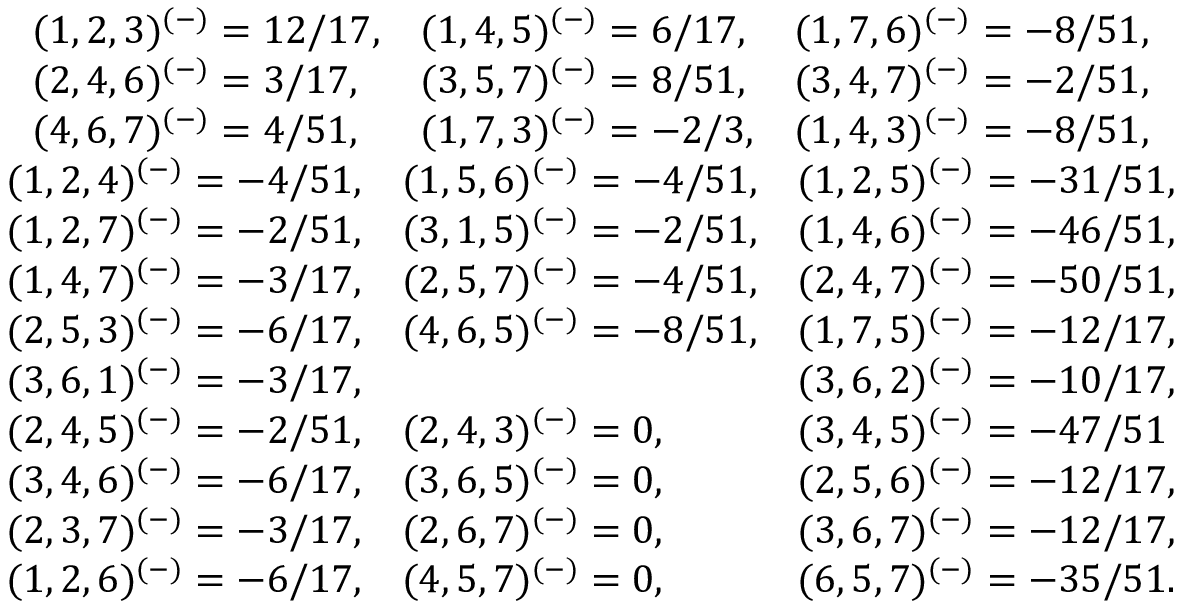Convert formula to latex. <formula><loc_0><loc_0><loc_500><loc_500>\begin{array} { c } { { \begin{array} { l l l } { { ( 1 , 2 , 3 ) ^ { ( - ) } = 1 2 / 1 7 , } } & { { ( 1 , 4 , 5 ) ^ { ( - ) } = 6 / 1 7 , } } & { { ( 1 , 7 , 6 ) ^ { ( - ) } = - 8 / 5 1 , } } \\ { { ( 2 , 4 , 6 ) ^ { ( - ) } = 3 / 1 7 , } } & { { ( 3 , 5 , 7 ) ^ { ( - ) } = 8 / 5 1 , } } & { { ( 3 , 4 , 7 ) ^ { ( - ) } = - 2 / 5 1 , } } \\ { { ( 4 , 6 , 7 ) ^ { ( - ) } = 4 / 5 1 , } } & { { ( 1 , 7 , 3 ) ^ { ( - ) } = - 2 / 3 , } } & { { ( 1 , 4 , 3 ) ^ { ( - ) } = - 8 / 5 1 , } } \end{array} } } \\ { { \begin{array} { l l l } { { ( 1 , 2 , 4 ) ^ { ( - ) } = - 4 / 5 1 , } } & { { ( 1 , 5 , 6 ) ^ { ( - ) } = - 4 / 5 1 , } } & { { ( 1 , 2 , 5 ) ^ { ( - ) } = - 3 1 / 5 1 , } } \\ { { ( 1 , 2 , 7 ) ^ { ( - ) } = - 2 / 5 1 , } } & { { ( 3 , 1 , 5 ) ^ { ( - ) } = - 2 / 5 1 , } } & { { ( 1 , 4 , 6 ) ^ { ( - ) } = - 4 6 / 5 1 , } } \\ { { ( 1 , 4 , 7 ) ^ { ( - ) } = - 3 / 1 7 , } } & { { ( 2 , 5 , 7 ) ^ { ( - ) } = - 4 / 5 1 , } } & { { ( 2 , 4 , 7 ) ^ { ( - ) } = - 5 0 / 5 1 , } } \\ { { ( 2 , 5 , 3 ) ^ { ( - ) } = - 6 / 1 7 , } } & { { ( 4 , 6 , 5 ) ^ { ( - ) } = - 8 / 5 1 , } } & { { ( 1 , 7 , 5 ) ^ { ( - ) } = - 1 2 / 1 7 , } } \\ { { ( 3 , 6 , 1 ) ^ { ( - ) } = - 3 / 1 7 , } } & { { ( 3 , 6 , 2 ) ^ { ( - ) } = - 1 0 / 1 7 , } } \\ { { ( 2 , 4 , 5 ) ^ { ( - ) } = - 2 / 5 1 , } } & { { ( 2 , 4 , 3 ) ^ { ( - ) } = 0 , } } & { { ( 3 , 4 , 5 ) ^ { ( - ) } = - 4 7 / 5 1 } } \\ { { ( 3 , 4 , 6 ) ^ { ( - ) } = - 6 / 1 7 , } } & { { ( 3 , 6 , 5 ) ^ { ( - ) } = 0 , } } & { { ( 2 , 5 , 6 ) ^ { ( - ) } = - 1 2 / 1 7 , } } \\ { { ( 2 , 3 , 7 ) ^ { ( - ) } = - 3 / 1 7 , } } & { { ( 2 , 6 , 7 ) ^ { ( - ) } = 0 , } } & { { ( 3 , 6 , 7 ) ^ { ( - ) } = - 1 2 / 1 7 , } } \\ { { ( 1 , 2 , 6 ) ^ { ( - ) } = - 6 / 1 7 , } } & { { ( 4 , 5 , 7 ) ^ { ( - ) } = 0 , } } & { { ( 6 , 5 , 7 ) ^ { ( - ) } = - 3 5 / 5 1 . } } \end{array} } } \end{array}</formula> 